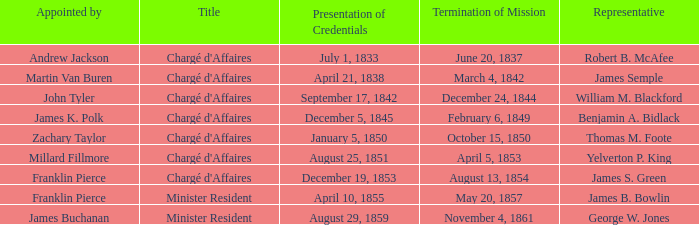Which Title has an Appointed by of Millard Fillmore? Chargé d'Affaires. 